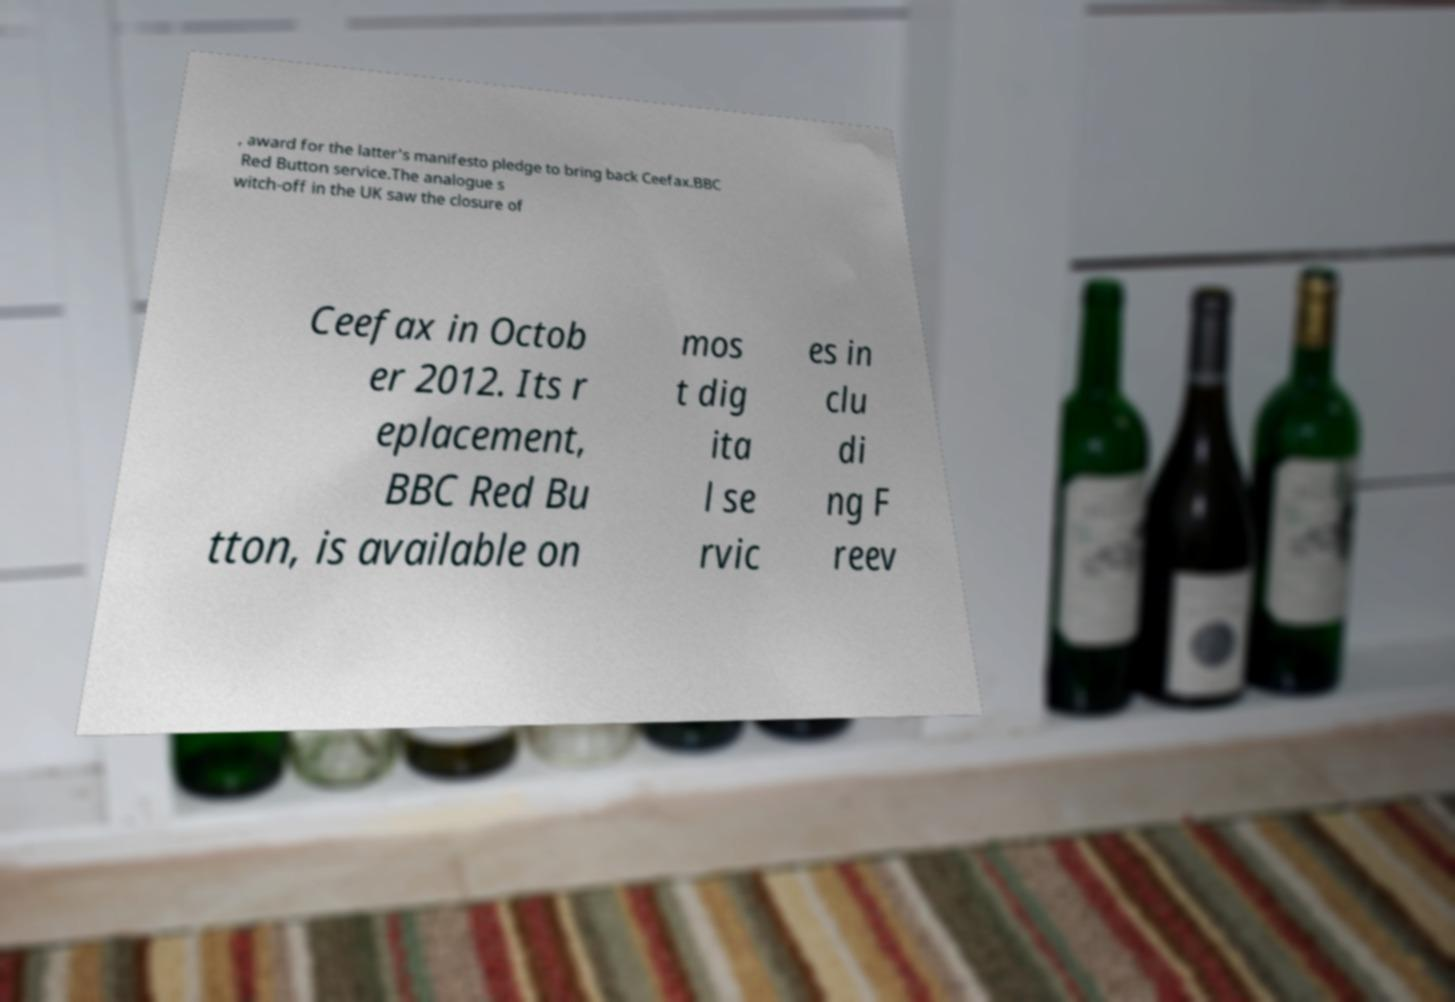Could you assist in decoding the text presented in this image and type it out clearly? , award for the latter's manifesto pledge to bring back Ceefax.BBC Red Button service.The analogue s witch-off in the UK saw the closure of Ceefax in Octob er 2012. Its r eplacement, BBC Red Bu tton, is available on mos t dig ita l se rvic es in clu di ng F reev 